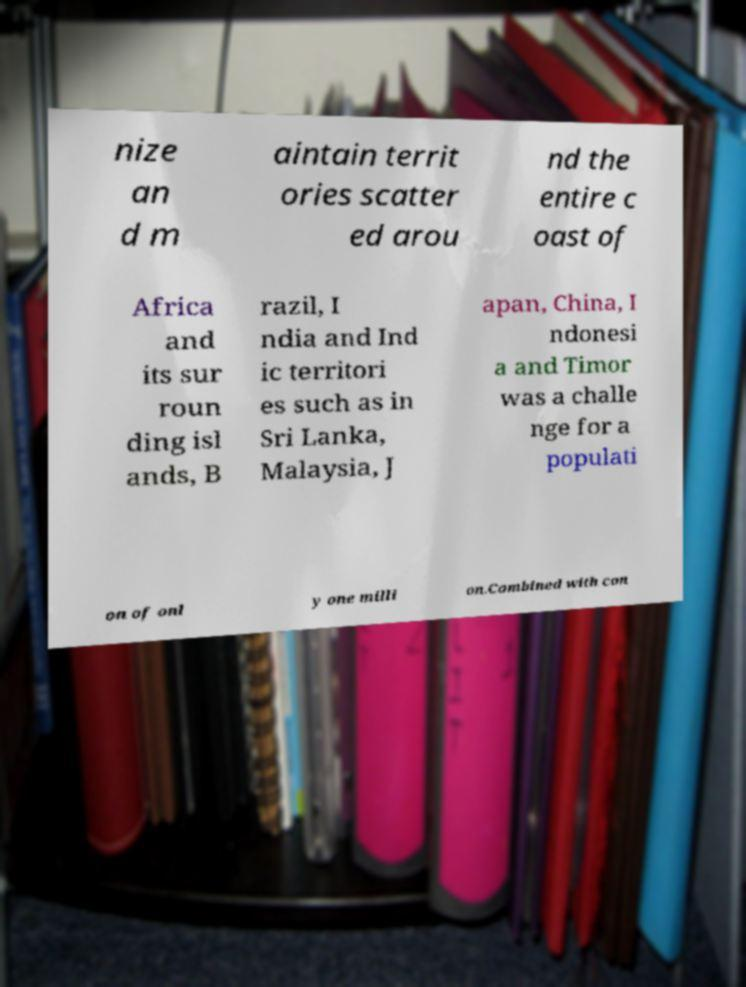Please identify and transcribe the text found in this image. nize an d m aintain territ ories scatter ed arou nd the entire c oast of Africa and its sur roun ding isl ands, B razil, I ndia and Ind ic territori es such as in Sri Lanka, Malaysia, J apan, China, I ndonesi a and Timor was a challe nge for a populati on of onl y one milli on.Combined with con 